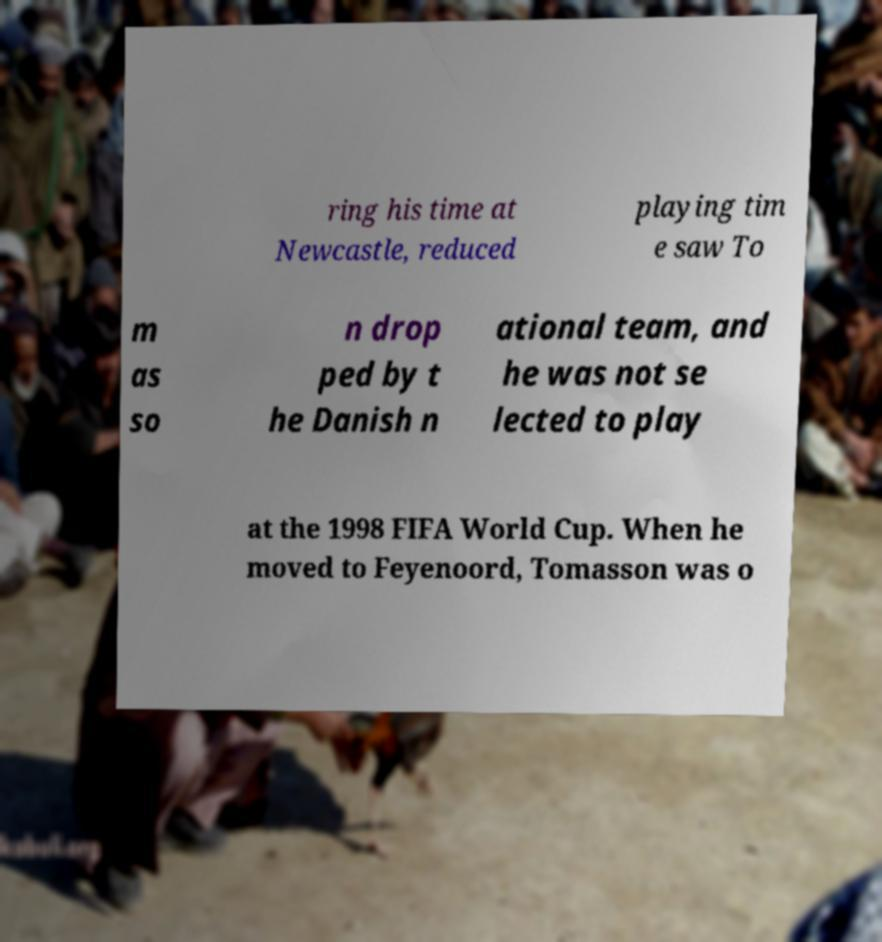Please read and relay the text visible in this image. What does it say? ring his time at Newcastle, reduced playing tim e saw To m as so n drop ped by t he Danish n ational team, and he was not se lected to play at the 1998 FIFA World Cup. When he moved to Feyenoord, Tomasson was o 